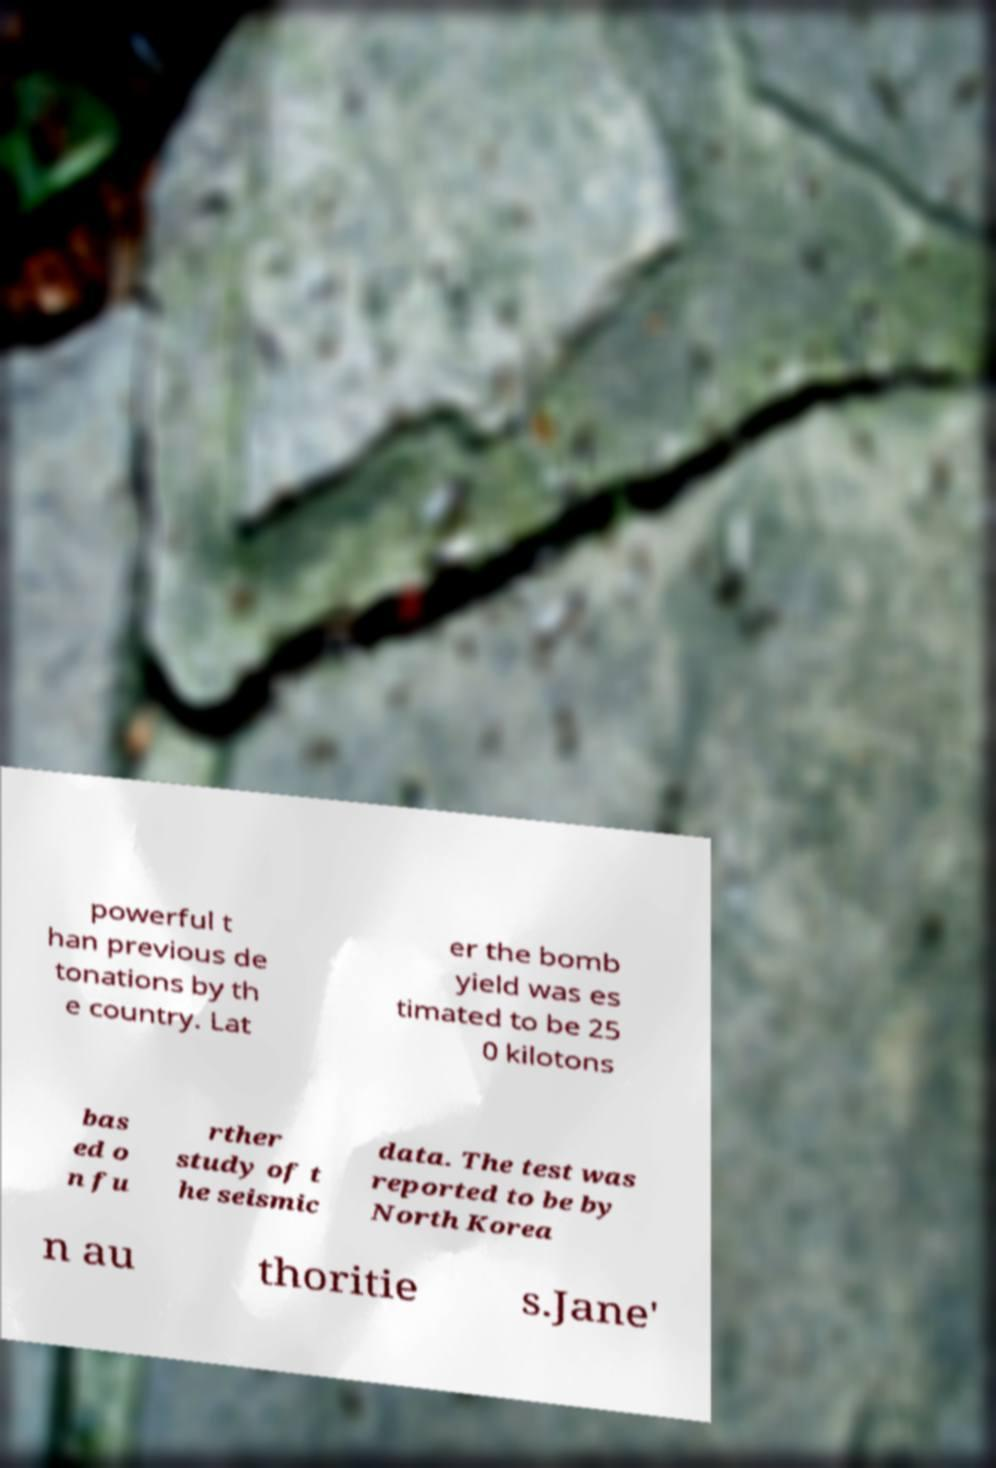What messages or text are displayed in this image? I need them in a readable, typed format. powerful t han previous de tonations by th e country. Lat er the bomb yield was es timated to be 25 0 kilotons bas ed o n fu rther study of t he seismic data. The test was reported to be by North Korea n au thoritie s.Jane' 